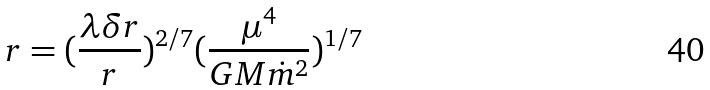Convert formula to latex. <formula><loc_0><loc_0><loc_500><loc_500>r = ( \frac { \lambda \delta r } { r } ) ^ { 2 / 7 } ( \frac { \mu ^ { 4 } } { G M \dot { m } ^ { 2 } } ) ^ { 1 / 7 }</formula> 